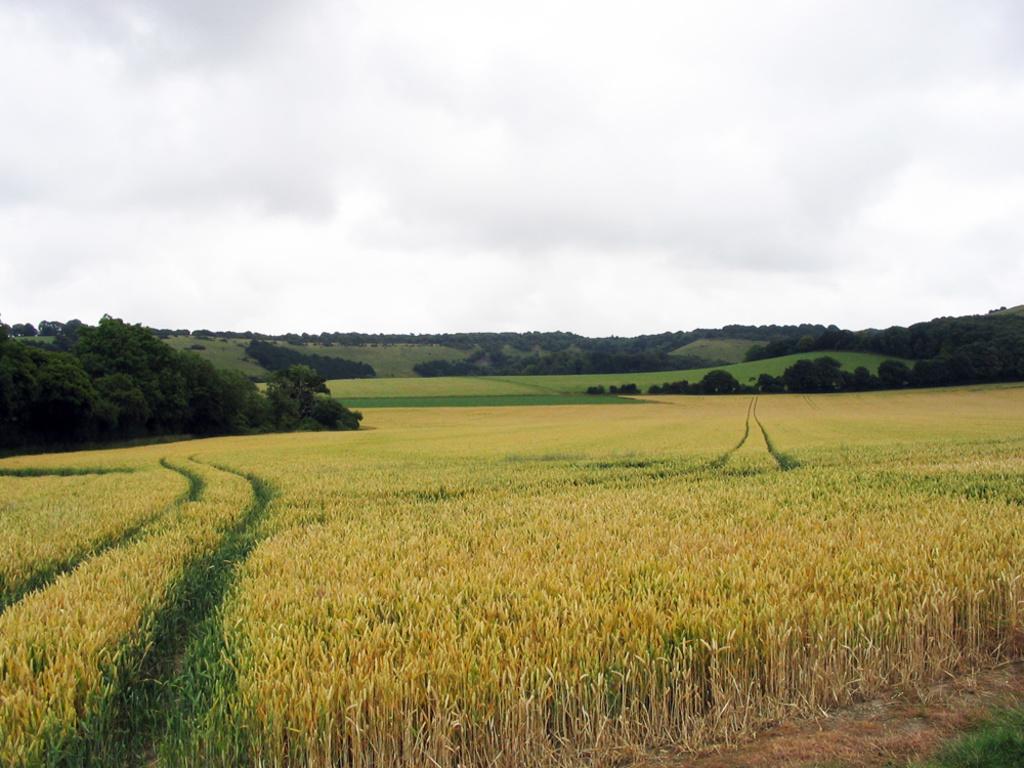How would you summarize this image in a sentence or two? In this image I can see the grass which is in yellow color. In the background I can see many trees, mountains, clouds and the sky. 